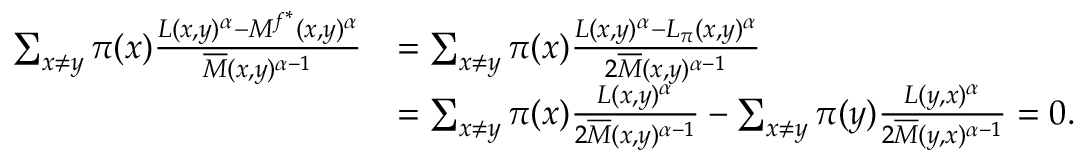Convert formula to latex. <formula><loc_0><loc_0><loc_500><loc_500>\begin{array} { r l } { \sum _ { x \neq y } \pi ( x ) \frac { L ( x , y ) ^ { \alpha } - M ^ { f ^ { * } } ( x , y ) ^ { \alpha } } { \overline { M } ( x , y ) ^ { \alpha - 1 } } } & { = \sum _ { x \neq y } \pi ( x ) \frac { L ( x , y ) ^ { \alpha } - L _ { \pi } ( x , y ) ^ { \alpha } } { 2 \overline { M } ( x , y ) ^ { \alpha - 1 } } } \\ & { = \sum _ { x \neq y } \pi ( x ) \frac { L ( x , y ) ^ { \alpha } } { 2 \overline { M } ( x , y ) ^ { \alpha - 1 } } - \sum _ { x \neq y } \pi ( y ) \frac { L ( y , x ) ^ { \alpha } } { 2 \overline { M } ( y , x ) ^ { \alpha - 1 } } = 0 . } \end{array}</formula> 